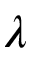Convert formula to latex. <formula><loc_0><loc_0><loc_500><loc_500>\lambda</formula> 